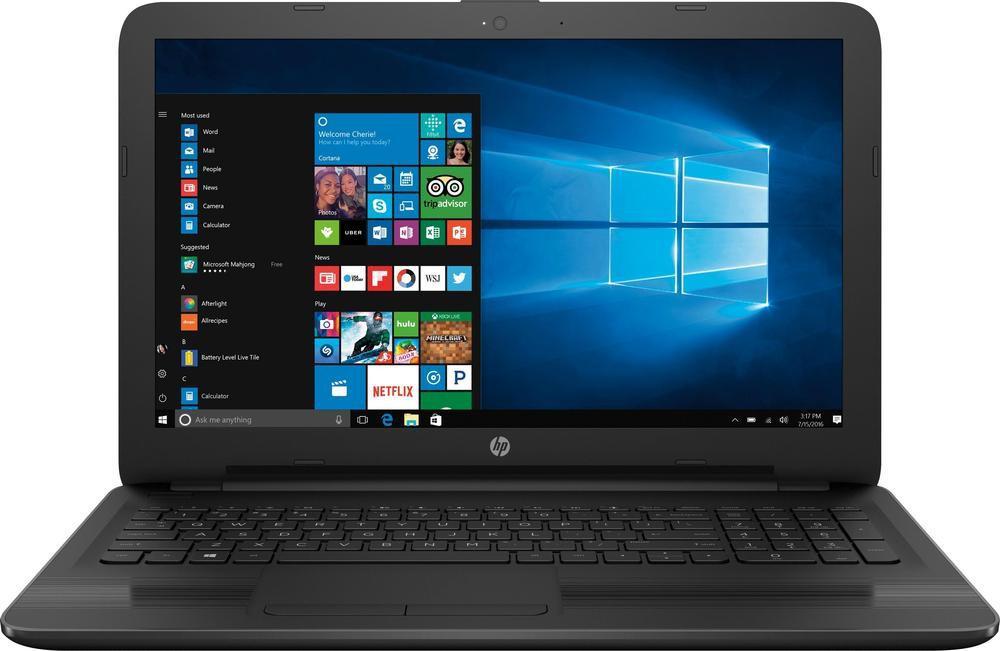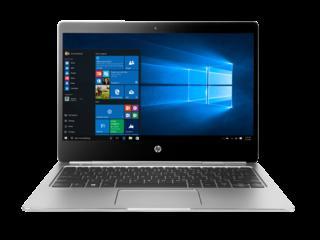The first image is the image on the left, the second image is the image on the right. Considering the images on both sides, is "All laptops in the paired pictures have the same screen image." valid? Answer yes or no. Yes. 